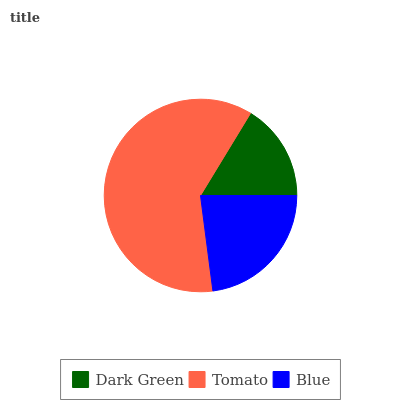Is Dark Green the minimum?
Answer yes or no. Yes. Is Tomato the maximum?
Answer yes or no. Yes. Is Blue the minimum?
Answer yes or no. No. Is Blue the maximum?
Answer yes or no. No. Is Tomato greater than Blue?
Answer yes or no. Yes. Is Blue less than Tomato?
Answer yes or no. Yes. Is Blue greater than Tomato?
Answer yes or no. No. Is Tomato less than Blue?
Answer yes or no. No. Is Blue the high median?
Answer yes or no. Yes. Is Blue the low median?
Answer yes or no. Yes. Is Dark Green the high median?
Answer yes or no. No. Is Tomato the low median?
Answer yes or no. No. 